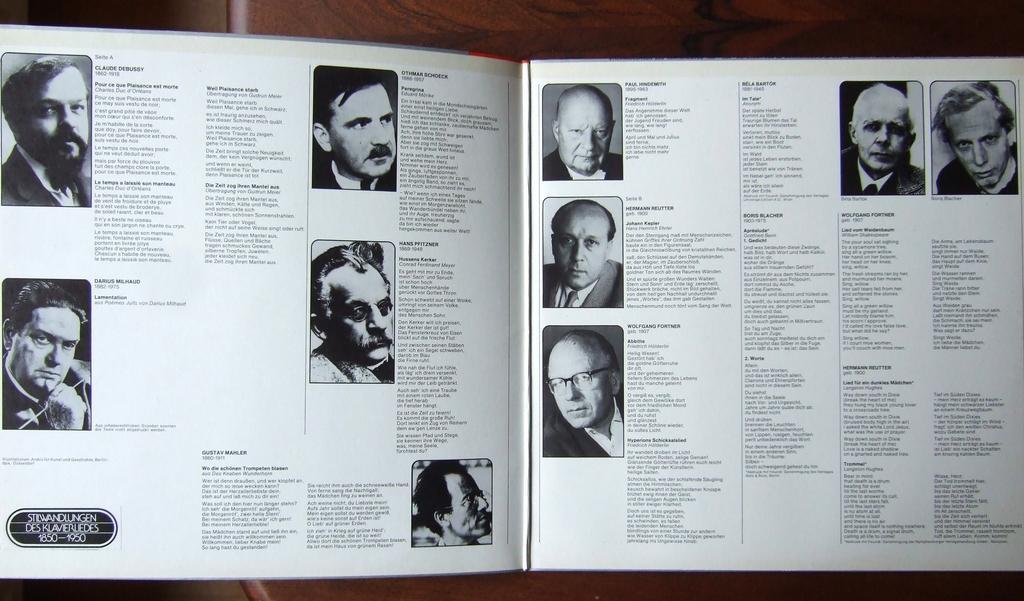Can you describe this image briefly? In this image there is a book with a few images of men and there is a text on the pages. 